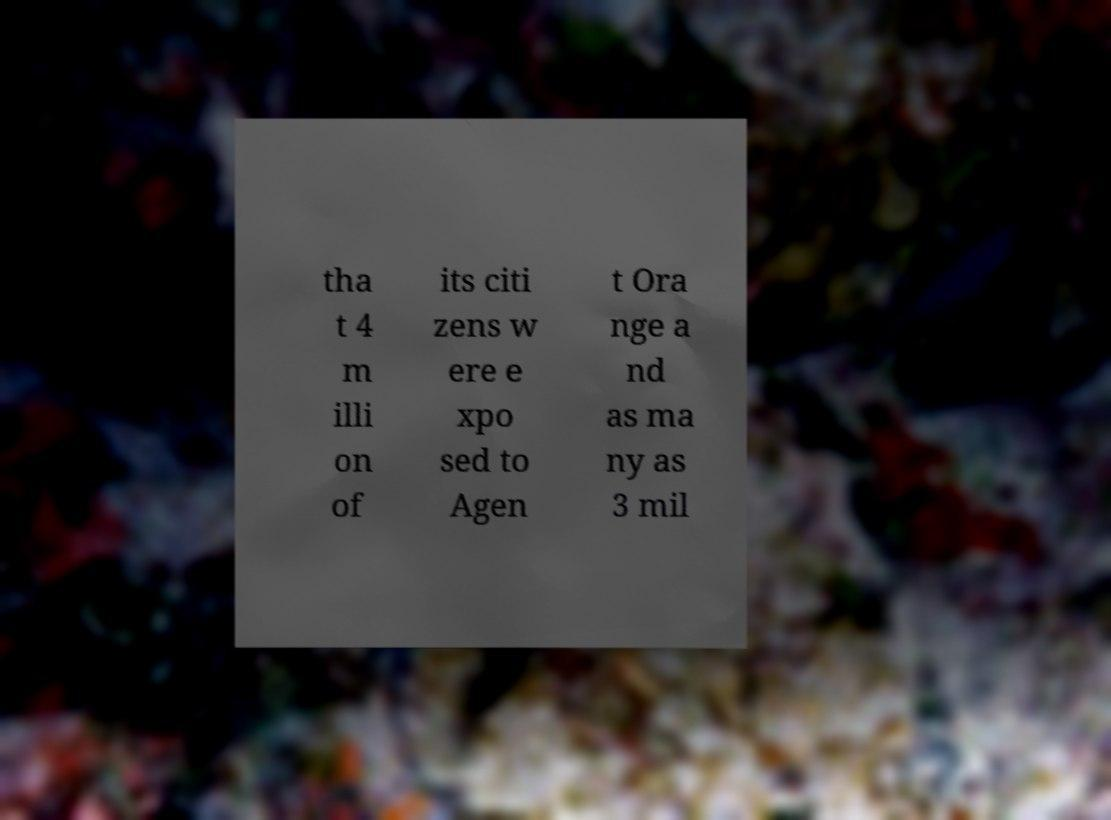Can you read and provide the text displayed in the image?This photo seems to have some interesting text. Can you extract and type it out for me? tha t 4 m illi on of its citi zens w ere e xpo sed to Agen t Ora nge a nd as ma ny as 3 mil 